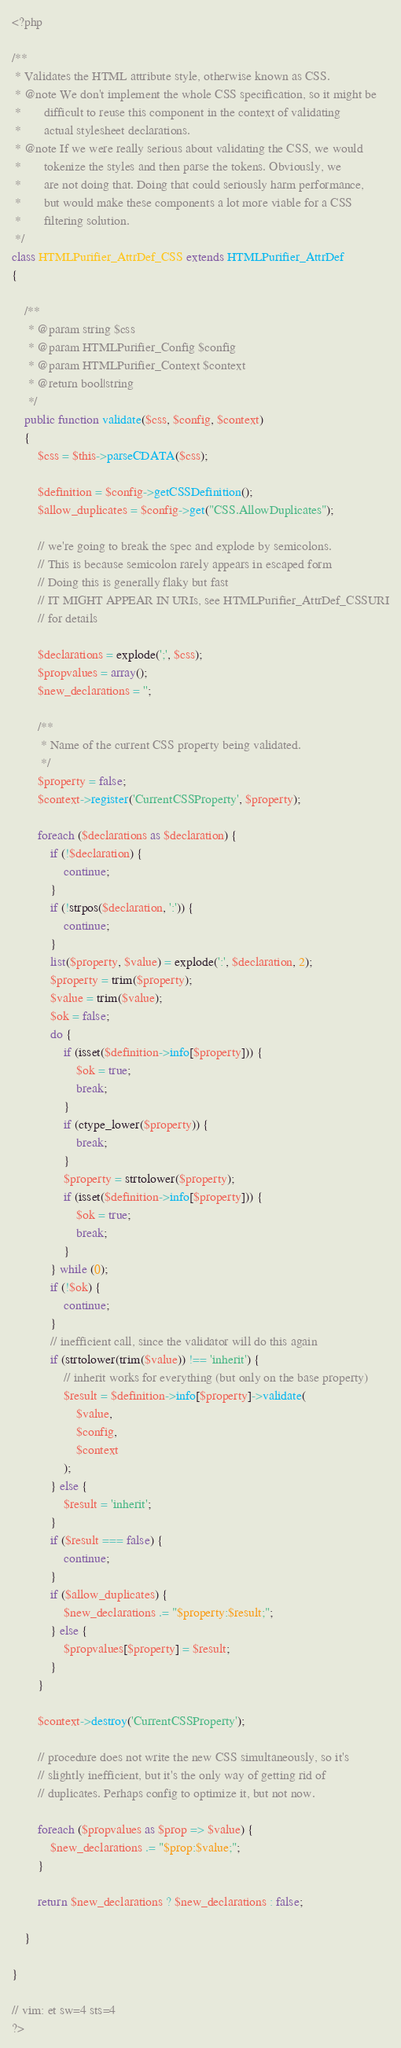<code> <loc_0><loc_0><loc_500><loc_500><_PHP_><?php

/**
 * Validates the HTML attribute style, otherwise known as CSS.
 * @note We don't implement the whole CSS specification, so it might be
 *       difficult to reuse this component in the context of validating
 *       actual stylesheet declarations.
 * @note If we were really serious about validating the CSS, we would
 *       tokenize the styles and then parse the tokens. Obviously, we
 *       are not doing that. Doing that could seriously harm performance,
 *       but would make these components a lot more viable for a CSS
 *       filtering solution.
 */
class HTMLPurifier_AttrDef_CSS extends HTMLPurifier_AttrDef
{

    /**
     * @param string $css
     * @param HTMLPurifier_Config $config
     * @param HTMLPurifier_Context $context
     * @return bool|string
     */
    public function validate($css, $config, $context)
    {
        $css = $this->parseCDATA($css);

        $definition = $config->getCSSDefinition();
        $allow_duplicates = $config->get("CSS.AllowDuplicates");

        // we're going to break the spec and explode by semicolons.
        // This is because semicolon rarely appears in escaped form
        // Doing this is generally flaky but fast
        // IT MIGHT APPEAR IN URIs, see HTMLPurifier_AttrDef_CSSURI
        // for details

        $declarations = explode(';', $css);
        $propvalues = array();
        $new_declarations = '';

        /**
         * Name of the current CSS property being validated.
         */
        $property = false;
        $context->register('CurrentCSSProperty', $property);

        foreach ($declarations as $declaration) {
            if (!$declaration) {
                continue;
            }
            if (!strpos($declaration, ':')) {
                continue;
            }
            list($property, $value) = explode(':', $declaration, 2);
            $property = trim($property);
            $value = trim($value);
            $ok = false;
            do {
                if (isset($definition->info[$property])) {
                    $ok = true;
                    break;
                }
                if (ctype_lower($property)) {
                    break;
                }
                $property = strtolower($property);
                if (isset($definition->info[$property])) {
                    $ok = true;
                    break;
                }
            } while (0);
            if (!$ok) {
                continue;
            }
            // inefficient call, since the validator will do this again
            if (strtolower(trim($value)) !== 'inherit') {
                // inherit works for everything (but only on the base property)
                $result = $definition->info[$property]->validate(
                    $value,
                    $config,
                    $context
                );
            } else {
                $result = 'inherit';
            }
            if ($result === false) {
                continue;
            }
            if ($allow_duplicates) {
                $new_declarations .= "$property:$result;";
            } else {
                $propvalues[$property] = $result;
            }
        }

        $context->destroy('CurrentCSSProperty');

        // procedure does not write the new CSS simultaneously, so it's
        // slightly inefficient, but it's the only way of getting rid of
        // duplicates. Perhaps config to optimize it, but not now.

        foreach ($propvalues as $prop => $value) {
            $new_declarations .= "$prop:$value;";
        }

        return $new_declarations ? $new_declarations : false;

    }

}

// vim: et sw=4 sts=4
?></code> 